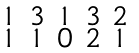Convert formula to latex. <formula><loc_0><loc_0><loc_500><loc_500>\begin{smallmatrix} 1 & 3 & 1 & 3 & 2 \\ 1 & 1 & 0 & 2 & 1 \end{smallmatrix}</formula> 